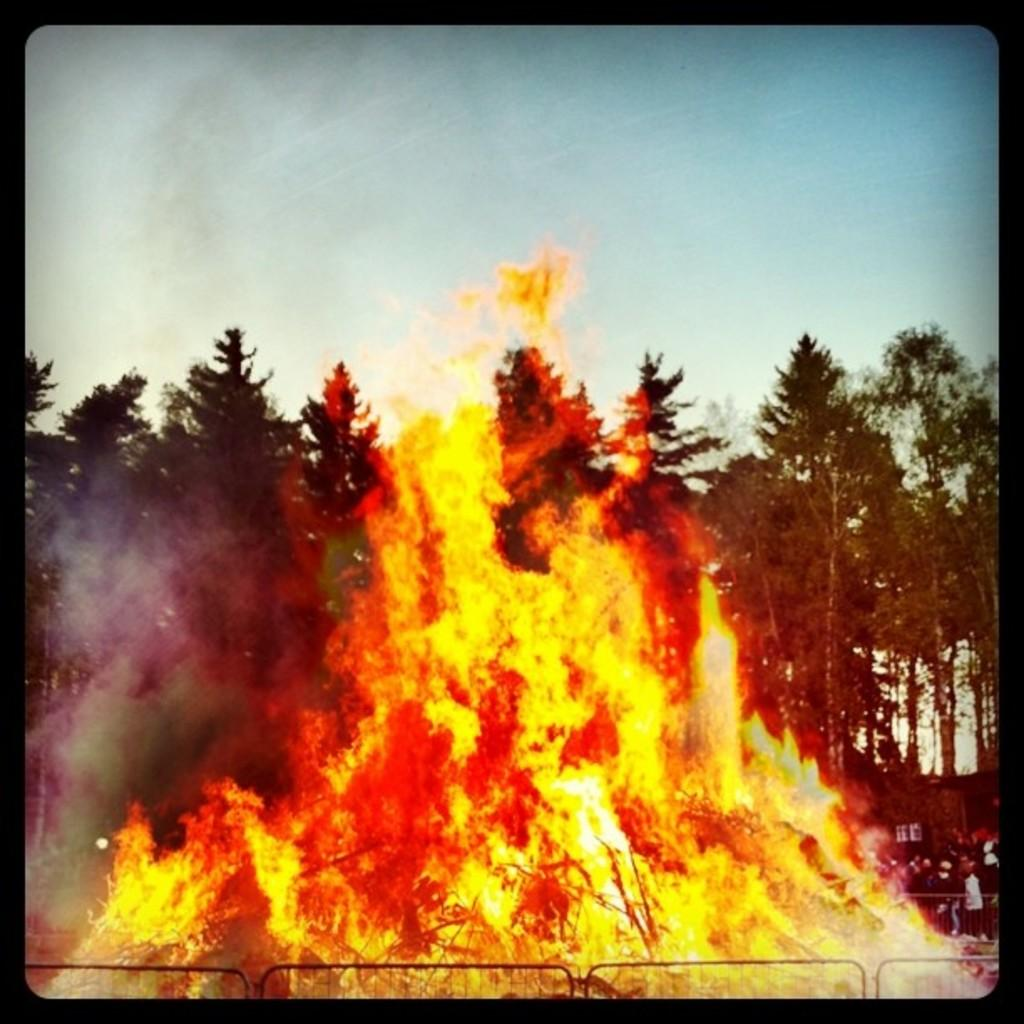What is the primary element in the image? There is fire in the image. Are there any living beings present in the image? Yes, there are people in the image. What type of natural environment is depicted in the image? There are many trees in the image, suggesting a forest or wooded area. What can be seen in the distance in the image? The sky is visible in the background of the image. What color is the rose in the image? There is no rose present in the image. What shape is the square in the image? There is no square present in the image. 